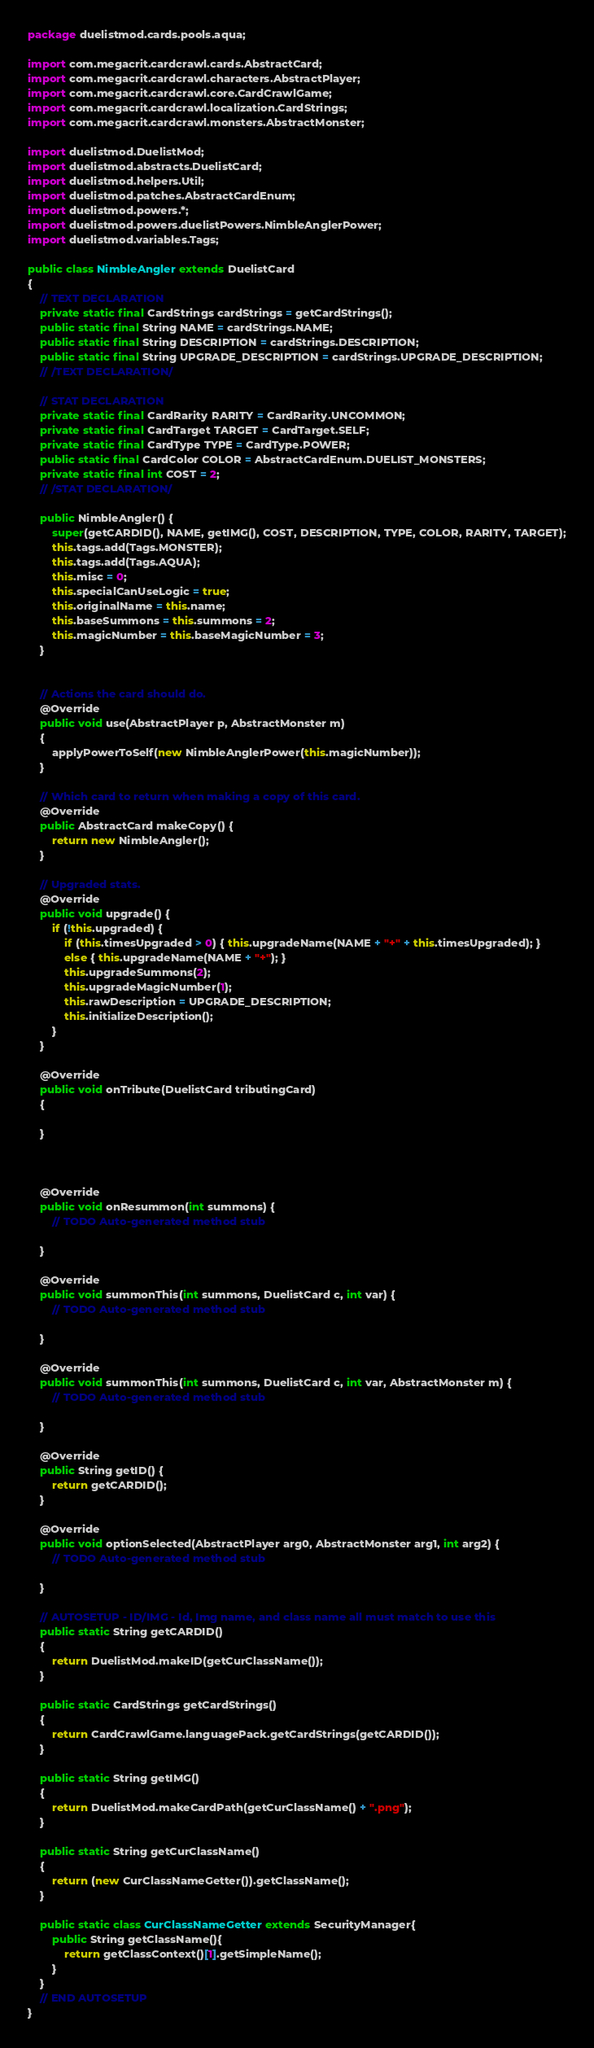Convert code to text. <code><loc_0><loc_0><loc_500><loc_500><_Java_>package duelistmod.cards.pools.aqua;

import com.megacrit.cardcrawl.cards.AbstractCard;
import com.megacrit.cardcrawl.characters.AbstractPlayer;
import com.megacrit.cardcrawl.core.CardCrawlGame;
import com.megacrit.cardcrawl.localization.CardStrings;
import com.megacrit.cardcrawl.monsters.AbstractMonster;

import duelistmod.DuelistMod;
import duelistmod.abstracts.DuelistCard;
import duelistmod.helpers.Util;
import duelistmod.patches.AbstractCardEnum;
import duelistmod.powers.*;
import duelistmod.powers.duelistPowers.NimbleAnglerPower;
import duelistmod.variables.Tags;

public class NimbleAngler extends DuelistCard 
{
    // TEXT DECLARATION
    private static final CardStrings cardStrings = getCardStrings();
    public static final String NAME = cardStrings.NAME;
    public static final String DESCRIPTION = cardStrings.DESCRIPTION;
    public static final String UPGRADE_DESCRIPTION = cardStrings.UPGRADE_DESCRIPTION;
    // /TEXT DECLARATION/

    // STAT DECLARATION
    private static final CardRarity RARITY = CardRarity.UNCOMMON;
    private static final CardTarget TARGET = CardTarget.SELF;
    private static final CardType TYPE = CardType.POWER;
    public static final CardColor COLOR = AbstractCardEnum.DUELIST_MONSTERS;
    private static final int COST = 2;
    // /STAT DECLARATION/

    public NimbleAngler() {
        super(getCARDID(), NAME, getIMG(), COST, DESCRIPTION, TYPE, COLOR, RARITY, TARGET);
        this.tags.add(Tags.MONSTER);
        this.tags.add(Tags.AQUA);
        this.misc = 0;
        this.specialCanUseLogic = true;
        this.originalName = this.name;
        this.baseSummons = this.summons = 2;
        this.magicNumber = this.baseMagicNumber = 3;
    }


    // Actions the card should do.
    @Override
    public void use(AbstractPlayer p, AbstractMonster m) 
    {
    	applyPowerToSelf(new NimbleAnglerPower(this.magicNumber));
    }

    // Which card to return when making a copy of this card.
    @Override
    public AbstractCard makeCopy() {
        return new NimbleAngler();
    }

    // Upgraded stats.
    @Override
    public void upgrade() {
        if (!this.upgraded) {
            if (this.timesUpgraded > 0) { this.upgradeName(NAME + "+" + this.timesUpgraded); }
	    	else { this.upgradeName(NAME + "+"); }
            this.upgradeSummons(2);
            this.upgradeMagicNumber(1);
            this.rawDescription = UPGRADE_DESCRIPTION;
            this.initializeDescription(); 
        }
    }

	@Override
	public void onTribute(DuelistCard tributingCard)
	{
		
	}

	

	@Override
	public void onResummon(int summons) {
		// TODO Auto-generated method stub
		
	}

	@Override
	public void summonThis(int summons, DuelistCard c, int var) {
		// TODO Auto-generated method stub
		
	}

	@Override
	public void summonThis(int summons, DuelistCard c, int var, AbstractMonster m) {
		// TODO Auto-generated method stub
		
	}

	@Override
	public String getID() {
		return getCARDID();
	}

	@Override
	public void optionSelected(AbstractPlayer arg0, AbstractMonster arg1, int arg2) {
		// TODO Auto-generated method stub
		
	}
	
	// AUTOSETUP - ID/IMG - Id, Img name, and class name all must match to use this
    public static String getCARDID()
    {
    	return DuelistMod.makeID(getCurClassName());
    }
    
	public static CardStrings getCardStrings()
    {
    	return CardCrawlGame.languagePack.getCardStrings(getCARDID());
    }
    
    public static String getIMG()
    {
    	return DuelistMod.makeCardPath(getCurClassName() + ".png");
    }
    
    public static String getCurClassName()
    {
    	return (new CurClassNameGetter()).getClassName();
    }

    public static class CurClassNameGetter extends SecurityManager{
    	public String getClassName(){
    		return getClassContext()[1].getSimpleName();
    	}
    }
    // END AUTOSETUP
}
</code> 